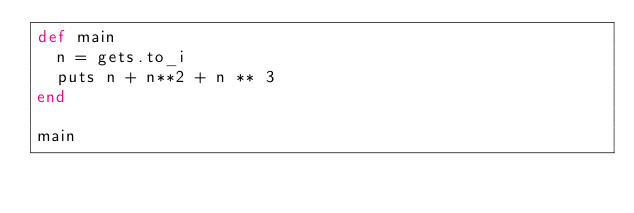Convert code to text. <code><loc_0><loc_0><loc_500><loc_500><_Ruby_>def main
  n = gets.to_i
  puts n + n**2 + n ** 3
end

main

</code> 